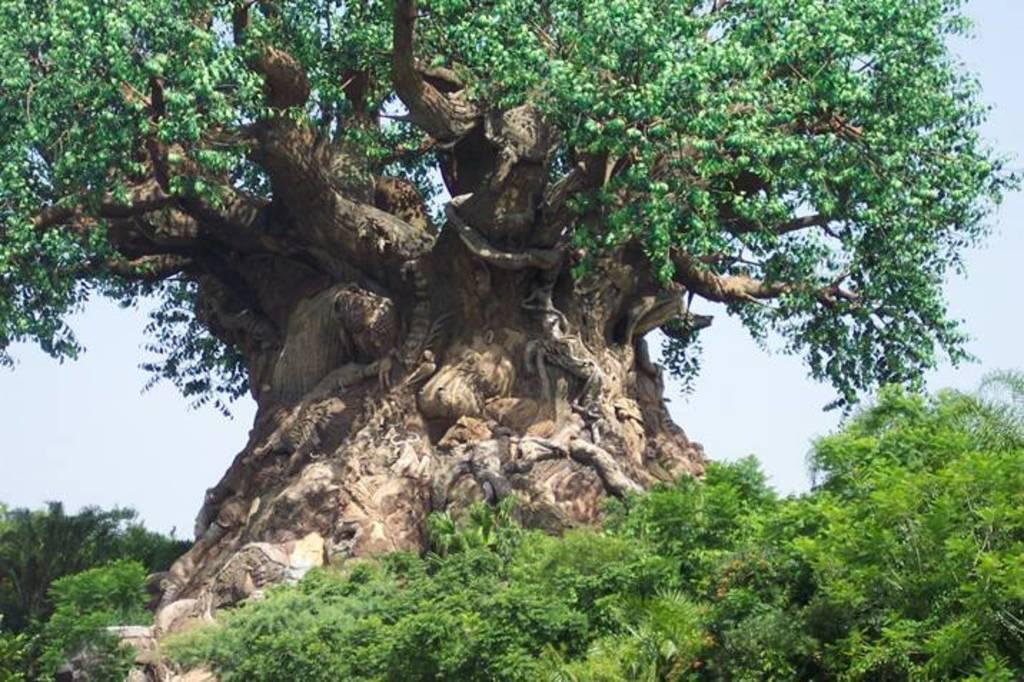What is the main feature in the image? There is a big tree in the image. What else can be seen at the bottom of the image? There are plants at the bottom of the image. What part of the sky is visible in the image? The sky is visible on the right side of the image. What can be observed in the sky? Clouds are present in the sky. How many cakes are being carried by the goose in the image? There is no goose or cake present in the image. What type of chicken can be seen perched on the tree in the image? There is no chicken present in the image; it only features a big tree, plants, and a sky with clouds. 